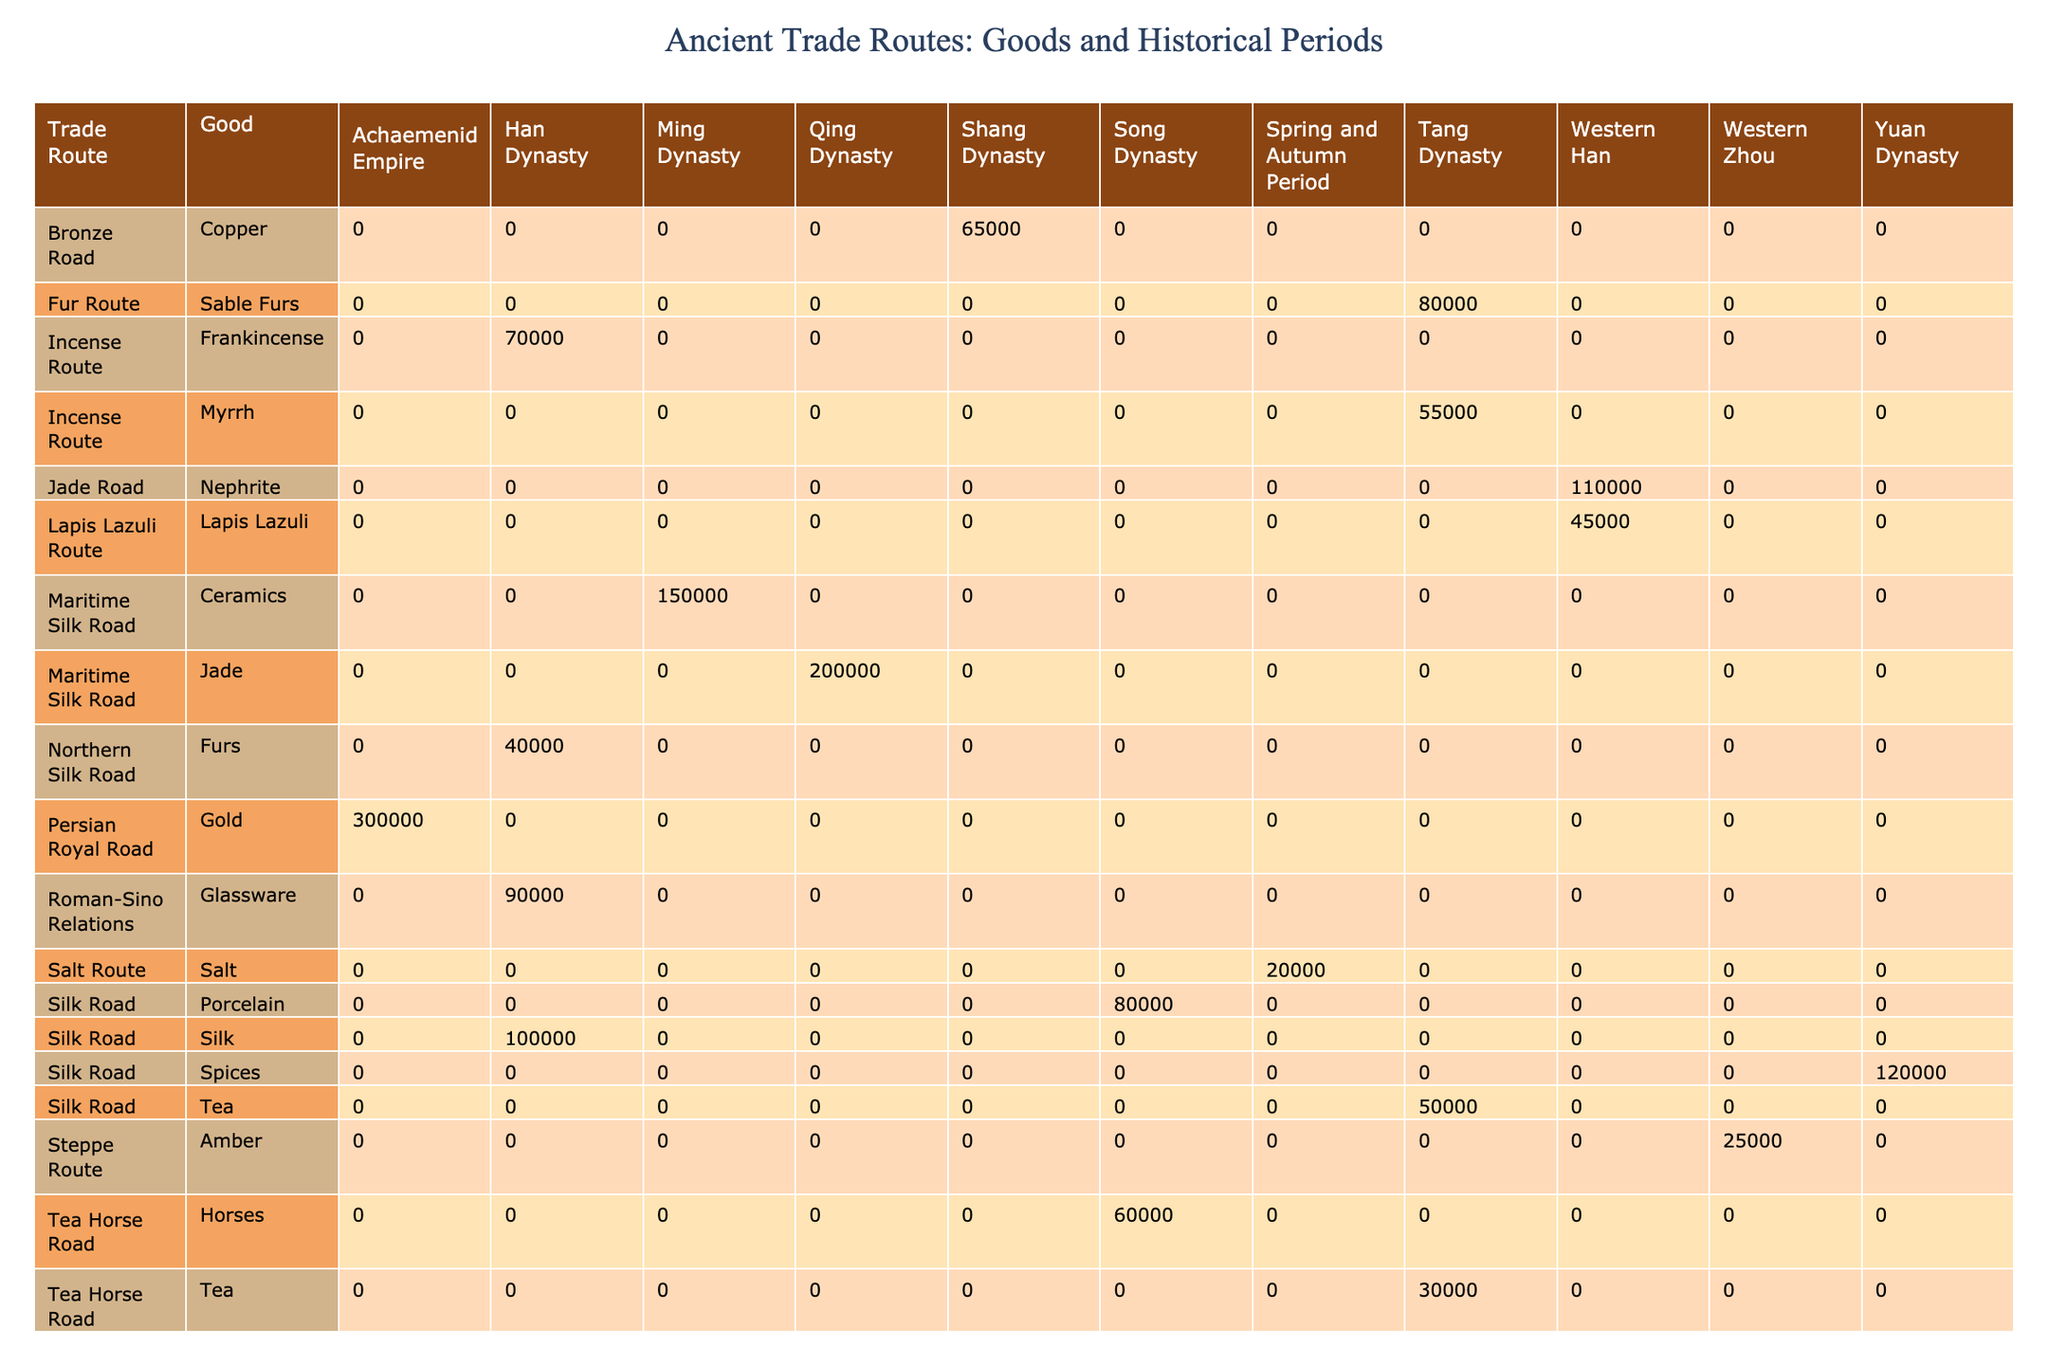What is the total value of silk traded along the Silk Road? According to the table, there is one entry for silk traded along the Silk Road during the Han Dynasty, which has a value of 100,000 gold coins. Therefore, the total value is simply 100,000.
Answer: 100000 Which trade route had the highest single good volume, and what was that good? By examining the table, the Maritime Silk Road has a good with the highest volume, ceramics, valued at 600 tons.
Answer: Maritime Silk Road, Ceramics How many different goods were traded along the Tea Horse Road? The table shows two goods traded along the Tea Horse Road: tea and horses. Hence, the total number of different goods is 2.
Answer: 2 What is the average value of goods traded during the Tang Dynasty? Summing the values of goods traded during the Tang Dynasty from the table: tea (50,000), myrrh (55,000), and horses (60,000), gives a total of 165,000. Dividing by 3 (the number of goods) results in an average of 55,000.
Answer: 55000 Is there any good with a value greater than 200,000 gold coins in the data? In analyzing the table values, the highest value noted for jade traded along the Maritime Silk Road is 200,000 gold coins. Hence, there are no goods with a value exceeding 200,000.
Answer: No Which historical period had the most diverse goods traded, based on the available data? The Tang Dynasty shows multiple entries for goods: tea, myrrh, and horses. However, other periods also have multiple entries, such as the Han and Song Dynasties. After analyzing, it concludes that the Tang Dynasty had three different goods listed, making it one of the most diverse.
Answer: Tang Dynasty What is the total volume of goods traded along the Silk Road? In the table, the total volumes of silk, tea, porcelain, and spices traded along the Silk Road amount to: 500 (silk) + 300 (tea) + 200 (porcelain) + 400 (spices) = 1400 tons total.
Answer: 1400 Which trade route had the most valuable single good? Scanning the table for the maximum value, the Persian Royal Road has gold valued at 300,000 gold coins, which is the highest single good value indicated in the data.
Answer: Persian Royal Road, Gold 